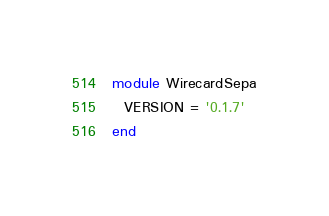<code> <loc_0><loc_0><loc_500><loc_500><_Ruby_>module WirecardSepa
  VERSION = '0.1.7'
end
</code> 